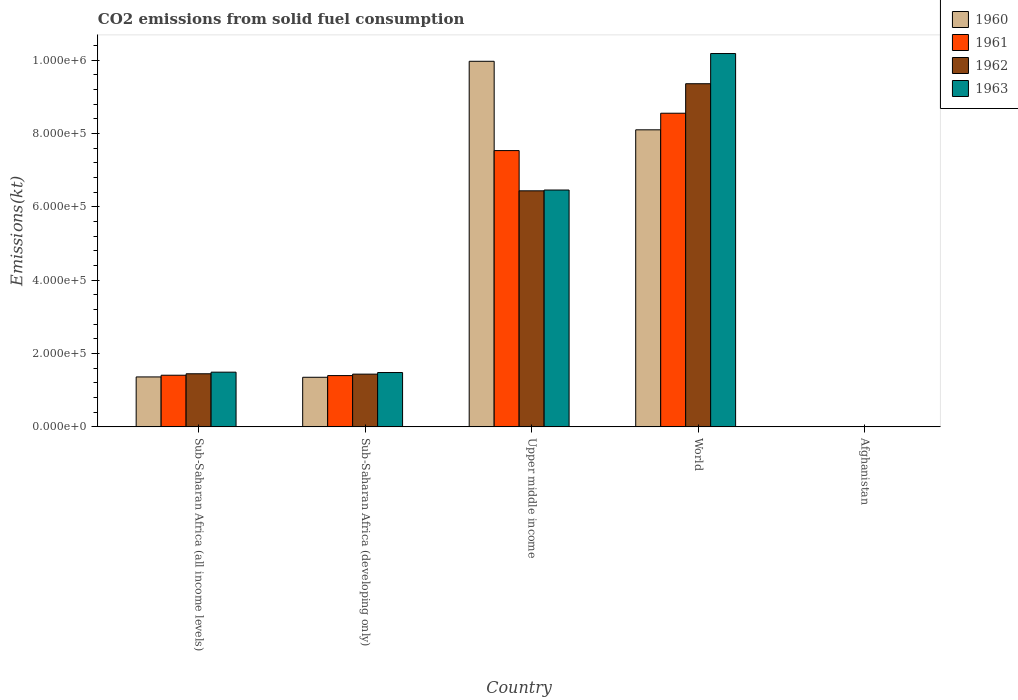Are the number of bars per tick equal to the number of legend labels?
Ensure brevity in your answer.  Yes. Are the number of bars on each tick of the X-axis equal?
Offer a very short reply. Yes. How many bars are there on the 5th tick from the left?
Your response must be concise. 4. What is the label of the 1st group of bars from the left?
Your answer should be very brief. Sub-Saharan Africa (all income levels). What is the amount of CO2 emitted in 1963 in Upper middle income?
Offer a terse response. 6.46e+05. Across all countries, what is the maximum amount of CO2 emitted in 1962?
Provide a short and direct response. 9.36e+05. Across all countries, what is the minimum amount of CO2 emitted in 1961?
Your answer should be compact. 176.02. In which country was the amount of CO2 emitted in 1960 maximum?
Ensure brevity in your answer.  Upper middle income. In which country was the amount of CO2 emitted in 1960 minimum?
Offer a very short reply. Afghanistan. What is the total amount of CO2 emitted in 1960 in the graph?
Keep it short and to the point. 2.08e+06. What is the difference between the amount of CO2 emitted in 1960 in Sub-Saharan Africa (developing only) and that in Upper middle income?
Ensure brevity in your answer.  -8.62e+05. What is the difference between the amount of CO2 emitted in 1960 in Afghanistan and the amount of CO2 emitted in 1962 in Sub-Saharan Africa (all income levels)?
Keep it short and to the point. -1.45e+05. What is the average amount of CO2 emitted in 1962 per country?
Keep it short and to the point. 3.74e+05. What is the difference between the amount of CO2 emitted of/in 1961 and amount of CO2 emitted of/in 1962 in World?
Your answer should be very brief. -8.05e+04. What is the ratio of the amount of CO2 emitted in 1960 in Sub-Saharan Africa (all income levels) to that in World?
Give a very brief answer. 0.17. What is the difference between the highest and the second highest amount of CO2 emitted in 1963?
Your answer should be very brief. -8.69e+05. What is the difference between the highest and the lowest amount of CO2 emitted in 1960?
Make the answer very short. 9.97e+05. What does the 1st bar from the left in Sub-Saharan Africa (developing only) represents?
Make the answer very short. 1960. What does the 2nd bar from the right in World represents?
Your response must be concise. 1962. How many countries are there in the graph?
Your response must be concise. 5. Where does the legend appear in the graph?
Your response must be concise. Top right. How are the legend labels stacked?
Your response must be concise. Vertical. What is the title of the graph?
Ensure brevity in your answer.  CO2 emissions from solid fuel consumption. What is the label or title of the X-axis?
Provide a succinct answer. Country. What is the label or title of the Y-axis?
Offer a very short reply. Emissions(kt). What is the Emissions(kt) of 1960 in Sub-Saharan Africa (all income levels)?
Offer a terse response. 1.36e+05. What is the Emissions(kt) of 1961 in Sub-Saharan Africa (all income levels)?
Make the answer very short. 1.41e+05. What is the Emissions(kt) of 1962 in Sub-Saharan Africa (all income levels)?
Ensure brevity in your answer.  1.45e+05. What is the Emissions(kt) of 1963 in Sub-Saharan Africa (all income levels)?
Your answer should be very brief. 1.49e+05. What is the Emissions(kt) in 1960 in Sub-Saharan Africa (developing only)?
Your response must be concise. 1.35e+05. What is the Emissions(kt) of 1961 in Sub-Saharan Africa (developing only)?
Your answer should be compact. 1.40e+05. What is the Emissions(kt) in 1962 in Sub-Saharan Africa (developing only)?
Provide a short and direct response. 1.44e+05. What is the Emissions(kt) in 1963 in Sub-Saharan Africa (developing only)?
Ensure brevity in your answer.  1.48e+05. What is the Emissions(kt) of 1960 in Upper middle income?
Provide a succinct answer. 9.97e+05. What is the Emissions(kt) in 1961 in Upper middle income?
Provide a succinct answer. 7.54e+05. What is the Emissions(kt) of 1962 in Upper middle income?
Offer a very short reply. 6.44e+05. What is the Emissions(kt) in 1963 in Upper middle income?
Provide a succinct answer. 6.46e+05. What is the Emissions(kt) of 1960 in World?
Ensure brevity in your answer.  8.10e+05. What is the Emissions(kt) in 1961 in World?
Provide a short and direct response. 8.56e+05. What is the Emissions(kt) in 1962 in World?
Make the answer very short. 9.36e+05. What is the Emissions(kt) of 1963 in World?
Offer a terse response. 1.02e+06. What is the Emissions(kt) of 1960 in Afghanistan?
Your answer should be compact. 128.34. What is the Emissions(kt) in 1961 in Afghanistan?
Keep it short and to the point. 176.02. What is the Emissions(kt) in 1962 in Afghanistan?
Offer a terse response. 297.03. What is the Emissions(kt) of 1963 in Afghanistan?
Ensure brevity in your answer.  264.02. Across all countries, what is the maximum Emissions(kt) of 1960?
Your answer should be compact. 9.97e+05. Across all countries, what is the maximum Emissions(kt) of 1961?
Provide a succinct answer. 8.56e+05. Across all countries, what is the maximum Emissions(kt) of 1962?
Ensure brevity in your answer.  9.36e+05. Across all countries, what is the maximum Emissions(kt) of 1963?
Ensure brevity in your answer.  1.02e+06. Across all countries, what is the minimum Emissions(kt) of 1960?
Offer a terse response. 128.34. Across all countries, what is the minimum Emissions(kt) of 1961?
Keep it short and to the point. 176.02. Across all countries, what is the minimum Emissions(kt) in 1962?
Your answer should be very brief. 297.03. Across all countries, what is the minimum Emissions(kt) in 1963?
Your answer should be compact. 264.02. What is the total Emissions(kt) of 1960 in the graph?
Ensure brevity in your answer.  2.08e+06. What is the total Emissions(kt) in 1961 in the graph?
Provide a short and direct response. 1.89e+06. What is the total Emissions(kt) of 1962 in the graph?
Give a very brief answer. 1.87e+06. What is the total Emissions(kt) in 1963 in the graph?
Your answer should be very brief. 1.96e+06. What is the difference between the Emissions(kt) in 1960 in Sub-Saharan Africa (all income levels) and that in Sub-Saharan Africa (developing only)?
Your response must be concise. 947.7. What is the difference between the Emissions(kt) of 1961 in Sub-Saharan Africa (all income levels) and that in Sub-Saharan Africa (developing only)?
Your answer should be compact. 979.79. What is the difference between the Emissions(kt) in 1962 in Sub-Saharan Africa (all income levels) and that in Sub-Saharan Africa (developing only)?
Your answer should be very brief. 1007.5. What is the difference between the Emissions(kt) in 1963 in Sub-Saharan Africa (all income levels) and that in Sub-Saharan Africa (developing only)?
Offer a terse response. 1037.94. What is the difference between the Emissions(kt) in 1960 in Sub-Saharan Africa (all income levels) and that in Upper middle income?
Provide a short and direct response. -8.61e+05. What is the difference between the Emissions(kt) of 1961 in Sub-Saharan Africa (all income levels) and that in Upper middle income?
Offer a terse response. -6.13e+05. What is the difference between the Emissions(kt) of 1962 in Sub-Saharan Africa (all income levels) and that in Upper middle income?
Your response must be concise. -4.99e+05. What is the difference between the Emissions(kt) in 1963 in Sub-Saharan Africa (all income levels) and that in Upper middle income?
Keep it short and to the point. -4.97e+05. What is the difference between the Emissions(kt) in 1960 in Sub-Saharan Africa (all income levels) and that in World?
Your answer should be compact. -6.74e+05. What is the difference between the Emissions(kt) of 1961 in Sub-Saharan Africa (all income levels) and that in World?
Your answer should be compact. -7.15e+05. What is the difference between the Emissions(kt) of 1962 in Sub-Saharan Africa (all income levels) and that in World?
Make the answer very short. -7.91e+05. What is the difference between the Emissions(kt) of 1963 in Sub-Saharan Africa (all income levels) and that in World?
Ensure brevity in your answer.  -8.69e+05. What is the difference between the Emissions(kt) of 1960 in Sub-Saharan Africa (all income levels) and that in Afghanistan?
Give a very brief answer. 1.36e+05. What is the difference between the Emissions(kt) in 1961 in Sub-Saharan Africa (all income levels) and that in Afghanistan?
Your answer should be compact. 1.41e+05. What is the difference between the Emissions(kt) in 1962 in Sub-Saharan Africa (all income levels) and that in Afghanistan?
Provide a short and direct response. 1.45e+05. What is the difference between the Emissions(kt) in 1963 in Sub-Saharan Africa (all income levels) and that in Afghanistan?
Your answer should be compact. 1.49e+05. What is the difference between the Emissions(kt) in 1960 in Sub-Saharan Africa (developing only) and that in Upper middle income?
Your response must be concise. -8.62e+05. What is the difference between the Emissions(kt) of 1961 in Sub-Saharan Africa (developing only) and that in Upper middle income?
Your answer should be compact. -6.14e+05. What is the difference between the Emissions(kt) in 1962 in Sub-Saharan Africa (developing only) and that in Upper middle income?
Keep it short and to the point. -5.00e+05. What is the difference between the Emissions(kt) of 1963 in Sub-Saharan Africa (developing only) and that in Upper middle income?
Give a very brief answer. -4.98e+05. What is the difference between the Emissions(kt) in 1960 in Sub-Saharan Africa (developing only) and that in World?
Provide a succinct answer. -6.75e+05. What is the difference between the Emissions(kt) of 1961 in Sub-Saharan Africa (developing only) and that in World?
Keep it short and to the point. -7.16e+05. What is the difference between the Emissions(kt) in 1962 in Sub-Saharan Africa (developing only) and that in World?
Make the answer very short. -7.92e+05. What is the difference between the Emissions(kt) in 1963 in Sub-Saharan Africa (developing only) and that in World?
Give a very brief answer. -8.70e+05. What is the difference between the Emissions(kt) in 1960 in Sub-Saharan Africa (developing only) and that in Afghanistan?
Offer a terse response. 1.35e+05. What is the difference between the Emissions(kt) in 1961 in Sub-Saharan Africa (developing only) and that in Afghanistan?
Your answer should be very brief. 1.40e+05. What is the difference between the Emissions(kt) in 1962 in Sub-Saharan Africa (developing only) and that in Afghanistan?
Offer a very short reply. 1.44e+05. What is the difference between the Emissions(kt) of 1963 in Sub-Saharan Africa (developing only) and that in Afghanistan?
Ensure brevity in your answer.  1.48e+05. What is the difference between the Emissions(kt) of 1960 in Upper middle income and that in World?
Offer a terse response. 1.87e+05. What is the difference between the Emissions(kt) in 1961 in Upper middle income and that in World?
Provide a succinct answer. -1.02e+05. What is the difference between the Emissions(kt) of 1962 in Upper middle income and that in World?
Give a very brief answer. -2.92e+05. What is the difference between the Emissions(kt) of 1963 in Upper middle income and that in World?
Your answer should be compact. -3.72e+05. What is the difference between the Emissions(kt) of 1960 in Upper middle income and that in Afghanistan?
Ensure brevity in your answer.  9.97e+05. What is the difference between the Emissions(kt) of 1961 in Upper middle income and that in Afghanistan?
Provide a short and direct response. 7.53e+05. What is the difference between the Emissions(kt) of 1962 in Upper middle income and that in Afghanistan?
Your answer should be very brief. 6.44e+05. What is the difference between the Emissions(kt) of 1963 in Upper middle income and that in Afghanistan?
Offer a terse response. 6.46e+05. What is the difference between the Emissions(kt) of 1960 in World and that in Afghanistan?
Ensure brevity in your answer.  8.10e+05. What is the difference between the Emissions(kt) of 1961 in World and that in Afghanistan?
Give a very brief answer. 8.55e+05. What is the difference between the Emissions(kt) in 1962 in World and that in Afghanistan?
Offer a terse response. 9.36e+05. What is the difference between the Emissions(kt) in 1963 in World and that in Afghanistan?
Offer a very short reply. 1.02e+06. What is the difference between the Emissions(kt) in 1960 in Sub-Saharan Africa (all income levels) and the Emissions(kt) in 1961 in Sub-Saharan Africa (developing only)?
Make the answer very short. -3634.8. What is the difference between the Emissions(kt) in 1960 in Sub-Saharan Africa (all income levels) and the Emissions(kt) in 1962 in Sub-Saharan Africa (developing only)?
Keep it short and to the point. -7591.49. What is the difference between the Emissions(kt) in 1960 in Sub-Saharan Africa (all income levels) and the Emissions(kt) in 1963 in Sub-Saharan Africa (developing only)?
Ensure brevity in your answer.  -1.19e+04. What is the difference between the Emissions(kt) in 1961 in Sub-Saharan Africa (all income levels) and the Emissions(kt) in 1962 in Sub-Saharan Africa (developing only)?
Offer a very short reply. -2976.9. What is the difference between the Emissions(kt) in 1961 in Sub-Saharan Africa (all income levels) and the Emissions(kt) in 1963 in Sub-Saharan Africa (developing only)?
Make the answer very short. -7322.24. What is the difference between the Emissions(kt) in 1962 in Sub-Saharan Africa (all income levels) and the Emissions(kt) in 1963 in Sub-Saharan Africa (developing only)?
Keep it short and to the point. -3337.84. What is the difference between the Emissions(kt) of 1960 in Sub-Saharan Africa (all income levels) and the Emissions(kt) of 1961 in Upper middle income?
Make the answer very short. -6.17e+05. What is the difference between the Emissions(kt) of 1960 in Sub-Saharan Africa (all income levels) and the Emissions(kt) of 1962 in Upper middle income?
Offer a very short reply. -5.08e+05. What is the difference between the Emissions(kt) in 1960 in Sub-Saharan Africa (all income levels) and the Emissions(kt) in 1963 in Upper middle income?
Your answer should be very brief. -5.10e+05. What is the difference between the Emissions(kt) of 1961 in Sub-Saharan Africa (all income levels) and the Emissions(kt) of 1962 in Upper middle income?
Your response must be concise. -5.03e+05. What is the difference between the Emissions(kt) in 1961 in Sub-Saharan Africa (all income levels) and the Emissions(kt) in 1963 in Upper middle income?
Your answer should be very brief. -5.05e+05. What is the difference between the Emissions(kt) in 1962 in Sub-Saharan Africa (all income levels) and the Emissions(kt) in 1963 in Upper middle income?
Ensure brevity in your answer.  -5.01e+05. What is the difference between the Emissions(kt) in 1960 in Sub-Saharan Africa (all income levels) and the Emissions(kt) in 1961 in World?
Offer a very short reply. -7.19e+05. What is the difference between the Emissions(kt) of 1960 in Sub-Saharan Africa (all income levels) and the Emissions(kt) of 1962 in World?
Offer a terse response. -8.00e+05. What is the difference between the Emissions(kt) in 1960 in Sub-Saharan Africa (all income levels) and the Emissions(kt) in 1963 in World?
Give a very brief answer. -8.82e+05. What is the difference between the Emissions(kt) in 1961 in Sub-Saharan Africa (all income levels) and the Emissions(kt) in 1962 in World?
Give a very brief answer. -7.95e+05. What is the difference between the Emissions(kt) in 1961 in Sub-Saharan Africa (all income levels) and the Emissions(kt) in 1963 in World?
Provide a succinct answer. -8.78e+05. What is the difference between the Emissions(kt) of 1962 in Sub-Saharan Africa (all income levels) and the Emissions(kt) of 1963 in World?
Ensure brevity in your answer.  -8.74e+05. What is the difference between the Emissions(kt) of 1960 in Sub-Saharan Africa (all income levels) and the Emissions(kt) of 1961 in Afghanistan?
Your answer should be compact. 1.36e+05. What is the difference between the Emissions(kt) of 1960 in Sub-Saharan Africa (all income levels) and the Emissions(kt) of 1962 in Afghanistan?
Offer a very short reply. 1.36e+05. What is the difference between the Emissions(kt) in 1960 in Sub-Saharan Africa (all income levels) and the Emissions(kt) in 1963 in Afghanistan?
Provide a succinct answer. 1.36e+05. What is the difference between the Emissions(kt) in 1961 in Sub-Saharan Africa (all income levels) and the Emissions(kt) in 1962 in Afghanistan?
Offer a very short reply. 1.41e+05. What is the difference between the Emissions(kt) in 1961 in Sub-Saharan Africa (all income levels) and the Emissions(kt) in 1963 in Afghanistan?
Give a very brief answer. 1.41e+05. What is the difference between the Emissions(kt) in 1962 in Sub-Saharan Africa (all income levels) and the Emissions(kt) in 1963 in Afghanistan?
Offer a terse response. 1.45e+05. What is the difference between the Emissions(kt) in 1960 in Sub-Saharan Africa (developing only) and the Emissions(kt) in 1961 in Upper middle income?
Keep it short and to the point. -6.18e+05. What is the difference between the Emissions(kt) of 1960 in Sub-Saharan Africa (developing only) and the Emissions(kt) of 1962 in Upper middle income?
Keep it short and to the point. -5.09e+05. What is the difference between the Emissions(kt) of 1960 in Sub-Saharan Africa (developing only) and the Emissions(kt) of 1963 in Upper middle income?
Your answer should be very brief. -5.11e+05. What is the difference between the Emissions(kt) in 1961 in Sub-Saharan Africa (developing only) and the Emissions(kt) in 1962 in Upper middle income?
Make the answer very short. -5.04e+05. What is the difference between the Emissions(kt) of 1961 in Sub-Saharan Africa (developing only) and the Emissions(kt) of 1963 in Upper middle income?
Your answer should be compact. -5.06e+05. What is the difference between the Emissions(kt) of 1962 in Sub-Saharan Africa (developing only) and the Emissions(kt) of 1963 in Upper middle income?
Provide a succinct answer. -5.02e+05. What is the difference between the Emissions(kt) in 1960 in Sub-Saharan Africa (developing only) and the Emissions(kt) in 1961 in World?
Give a very brief answer. -7.20e+05. What is the difference between the Emissions(kt) in 1960 in Sub-Saharan Africa (developing only) and the Emissions(kt) in 1962 in World?
Provide a short and direct response. -8.01e+05. What is the difference between the Emissions(kt) in 1960 in Sub-Saharan Africa (developing only) and the Emissions(kt) in 1963 in World?
Ensure brevity in your answer.  -8.83e+05. What is the difference between the Emissions(kt) in 1961 in Sub-Saharan Africa (developing only) and the Emissions(kt) in 1962 in World?
Give a very brief answer. -7.96e+05. What is the difference between the Emissions(kt) in 1961 in Sub-Saharan Africa (developing only) and the Emissions(kt) in 1963 in World?
Give a very brief answer. -8.79e+05. What is the difference between the Emissions(kt) of 1962 in Sub-Saharan Africa (developing only) and the Emissions(kt) of 1963 in World?
Offer a very short reply. -8.75e+05. What is the difference between the Emissions(kt) of 1960 in Sub-Saharan Africa (developing only) and the Emissions(kt) of 1961 in Afghanistan?
Keep it short and to the point. 1.35e+05. What is the difference between the Emissions(kt) in 1960 in Sub-Saharan Africa (developing only) and the Emissions(kt) in 1962 in Afghanistan?
Ensure brevity in your answer.  1.35e+05. What is the difference between the Emissions(kt) of 1960 in Sub-Saharan Africa (developing only) and the Emissions(kt) of 1963 in Afghanistan?
Offer a terse response. 1.35e+05. What is the difference between the Emissions(kt) in 1961 in Sub-Saharan Africa (developing only) and the Emissions(kt) in 1962 in Afghanistan?
Your answer should be very brief. 1.40e+05. What is the difference between the Emissions(kt) in 1961 in Sub-Saharan Africa (developing only) and the Emissions(kt) in 1963 in Afghanistan?
Your answer should be very brief. 1.40e+05. What is the difference between the Emissions(kt) of 1962 in Sub-Saharan Africa (developing only) and the Emissions(kt) of 1963 in Afghanistan?
Offer a very short reply. 1.44e+05. What is the difference between the Emissions(kt) in 1960 in Upper middle income and the Emissions(kt) in 1961 in World?
Ensure brevity in your answer.  1.42e+05. What is the difference between the Emissions(kt) in 1960 in Upper middle income and the Emissions(kt) in 1962 in World?
Offer a terse response. 6.12e+04. What is the difference between the Emissions(kt) in 1960 in Upper middle income and the Emissions(kt) in 1963 in World?
Your answer should be compact. -2.12e+04. What is the difference between the Emissions(kt) in 1961 in Upper middle income and the Emissions(kt) in 1962 in World?
Give a very brief answer. -1.82e+05. What is the difference between the Emissions(kt) in 1961 in Upper middle income and the Emissions(kt) in 1963 in World?
Your response must be concise. -2.65e+05. What is the difference between the Emissions(kt) of 1962 in Upper middle income and the Emissions(kt) of 1963 in World?
Your answer should be very brief. -3.74e+05. What is the difference between the Emissions(kt) of 1960 in Upper middle income and the Emissions(kt) of 1961 in Afghanistan?
Offer a terse response. 9.97e+05. What is the difference between the Emissions(kt) of 1960 in Upper middle income and the Emissions(kt) of 1962 in Afghanistan?
Provide a short and direct response. 9.97e+05. What is the difference between the Emissions(kt) of 1960 in Upper middle income and the Emissions(kt) of 1963 in Afghanistan?
Your answer should be compact. 9.97e+05. What is the difference between the Emissions(kt) in 1961 in Upper middle income and the Emissions(kt) in 1962 in Afghanistan?
Give a very brief answer. 7.53e+05. What is the difference between the Emissions(kt) in 1961 in Upper middle income and the Emissions(kt) in 1963 in Afghanistan?
Give a very brief answer. 7.53e+05. What is the difference between the Emissions(kt) in 1962 in Upper middle income and the Emissions(kt) in 1963 in Afghanistan?
Your answer should be compact. 6.44e+05. What is the difference between the Emissions(kt) of 1960 in World and the Emissions(kt) of 1961 in Afghanistan?
Your answer should be compact. 8.10e+05. What is the difference between the Emissions(kt) of 1960 in World and the Emissions(kt) of 1962 in Afghanistan?
Make the answer very short. 8.10e+05. What is the difference between the Emissions(kt) in 1960 in World and the Emissions(kt) in 1963 in Afghanistan?
Keep it short and to the point. 8.10e+05. What is the difference between the Emissions(kt) of 1961 in World and the Emissions(kt) of 1962 in Afghanistan?
Offer a terse response. 8.55e+05. What is the difference between the Emissions(kt) in 1961 in World and the Emissions(kt) in 1963 in Afghanistan?
Give a very brief answer. 8.55e+05. What is the difference between the Emissions(kt) in 1962 in World and the Emissions(kt) in 1963 in Afghanistan?
Make the answer very short. 9.36e+05. What is the average Emissions(kt) in 1960 per country?
Give a very brief answer. 4.16e+05. What is the average Emissions(kt) in 1961 per country?
Keep it short and to the point. 3.78e+05. What is the average Emissions(kt) in 1962 per country?
Provide a succinct answer. 3.74e+05. What is the average Emissions(kt) in 1963 per country?
Provide a short and direct response. 3.92e+05. What is the difference between the Emissions(kt) of 1960 and Emissions(kt) of 1961 in Sub-Saharan Africa (all income levels)?
Provide a succinct answer. -4614.59. What is the difference between the Emissions(kt) of 1960 and Emissions(kt) of 1962 in Sub-Saharan Africa (all income levels)?
Make the answer very short. -8598.99. What is the difference between the Emissions(kt) of 1960 and Emissions(kt) of 1963 in Sub-Saharan Africa (all income levels)?
Your response must be concise. -1.30e+04. What is the difference between the Emissions(kt) of 1961 and Emissions(kt) of 1962 in Sub-Saharan Africa (all income levels)?
Keep it short and to the point. -3984.4. What is the difference between the Emissions(kt) in 1961 and Emissions(kt) in 1963 in Sub-Saharan Africa (all income levels)?
Make the answer very short. -8360.18. What is the difference between the Emissions(kt) of 1962 and Emissions(kt) of 1963 in Sub-Saharan Africa (all income levels)?
Keep it short and to the point. -4375.77. What is the difference between the Emissions(kt) in 1960 and Emissions(kt) in 1961 in Sub-Saharan Africa (developing only)?
Keep it short and to the point. -4582.5. What is the difference between the Emissions(kt) of 1960 and Emissions(kt) of 1962 in Sub-Saharan Africa (developing only)?
Your answer should be very brief. -8539.18. What is the difference between the Emissions(kt) of 1960 and Emissions(kt) of 1963 in Sub-Saharan Africa (developing only)?
Provide a short and direct response. -1.29e+04. What is the difference between the Emissions(kt) of 1961 and Emissions(kt) of 1962 in Sub-Saharan Africa (developing only)?
Offer a very short reply. -3956.69. What is the difference between the Emissions(kt) of 1961 and Emissions(kt) of 1963 in Sub-Saharan Africa (developing only)?
Your response must be concise. -8302.03. What is the difference between the Emissions(kt) in 1962 and Emissions(kt) in 1963 in Sub-Saharan Africa (developing only)?
Keep it short and to the point. -4345.34. What is the difference between the Emissions(kt) of 1960 and Emissions(kt) of 1961 in Upper middle income?
Provide a short and direct response. 2.44e+05. What is the difference between the Emissions(kt) in 1960 and Emissions(kt) in 1962 in Upper middle income?
Ensure brevity in your answer.  3.53e+05. What is the difference between the Emissions(kt) in 1960 and Emissions(kt) in 1963 in Upper middle income?
Ensure brevity in your answer.  3.51e+05. What is the difference between the Emissions(kt) of 1961 and Emissions(kt) of 1962 in Upper middle income?
Provide a succinct answer. 1.10e+05. What is the difference between the Emissions(kt) in 1961 and Emissions(kt) in 1963 in Upper middle income?
Offer a terse response. 1.08e+05. What is the difference between the Emissions(kt) in 1962 and Emissions(kt) in 1963 in Upper middle income?
Your response must be concise. -2192.22. What is the difference between the Emissions(kt) of 1960 and Emissions(kt) of 1961 in World?
Offer a terse response. -4.53e+04. What is the difference between the Emissions(kt) in 1960 and Emissions(kt) in 1962 in World?
Your response must be concise. -1.26e+05. What is the difference between the Emissions(kt) of 1960 and Emissions(kt) of 1963 in World?
Provide a short and direct response. -2.08e+05. What is the difference between the Emissions(kt) in 1961 and Emissions(kt) in 1962 in World?
Your answer should be compact. -8.05e+04. What is the difference between the Emissions(kt) of 1961 and Emissions(kt) of 1963 in World?
Make the answer very short. -1.63e+05. What is the difference between the Emissions(kt) of 1962 and Emissions(kt) of 1963 in World?
Your answer should be very brief. -8.24e+04. What is the difference between the Emissions(kt) of 1960 and Emissions(kt) of 1961 in Afghanistan?
Keep it short and to the point. -47.67. What is the difference between the Emissions(kt) in 1960 and Emissions(kt) in 1962 in Afghanistan?
Provide a short and direct response. -168.68. What is the difference between the Emissions(kt) of 1960 and Emissions(kt) of 1963 in Afghanistan?
Your answer should be very brief. -135.68. What is the difference between the Emissions(kt) in 1961 and Emissions(kt) in 1962 in Afghanistan?
Your answer should be very brief. -121.01. What is the difference between the Emissions(kt) of 1961 and Emissions(kt) of 1963 in Afghanistan?
Keep it short and to the point. -88.01. What is the difference between the Emissions(kt) of 1962 and Emissions(kt) of 1963 in Afghanistan?
Make the answer very short. 33. What is the ratio of the Emissions(kt) in 1961 in Sub-Saharan Africa (all income levels) to that in Sub-Saharan Africa (developing only)?
Make the answer very short. 1.01. What is the ratio of the Emissions(kt) in 1960 in Sub-Saharan Africa (all income levels) to that in Upper middle income?
Keep it short and to the point. 0.14. What is the ratio of the Emissions(kt) in 1961 in Sub-Saharan Africa (all income levels) to that in Upper middle income?
Your answer should be very brief. 0.19. What is the ratio of the Emissions(kt) in 1962 in Sub-Saharan Africa (all income levels) to that in Upper middle income?
Offer a very short reply. 0.23. What is the ratio of the Emissions(kt) in 1963 in Sub-Saharan Africa (all income levels) to that in Upper middle income?
Give a very brief answer. 0.23. What is the ratio of the Emissions(kt) in 1960 in Sub-Saharan Africa (all income levels) to that in World?
Offer a very short reply. 0.17. What is the ratio of the Emissions(kt) of 1961 in Sub-Saharan Africa (all income levels) to that in World?
Your answer should be compact. 0.16. What is the ratio of the Emissions(kt) of 1962 in Sub-Saharan Africa (all income levels) to that in World?
Offer a very short reply. 0.15. What is the ratio of the Emissions(kt) in 1963 in Sub-Saharan Africa (all income levels) to that in World?
Offer a terse response. 0.15. What is the ratio of the Emissions(kt) in 1960 in Sub-Saharan Africa (all income levels) to that in Afghanistan?
Your answer should be compact. 1061.66. What is the ratio of the Emissions(kt) of 1961 in Sub-Saharan Africa (all income levels) to that in Afghanistan?
Give a very brief answer. 800.34. What is the ratio of the Emissions(kt) of 1962 in Sub-Saharan Africa (all income levels) to that in Afghanistan?
Make the answer very short. 487.69. What is the ratio of the Emissions(kt) in 1963 in Sub-Saharan Africa (all income levels) to that in Afghanistan?
Ensure brevity in your answer.  565.22. What is the ratio of the Emissions(kt) in 1960 in Sub-Saharan Africa (developing only) to that in Upper middle income?
Ensure brevity in your answer.  0.14. What is the ratio of the Emissions(kt) in 1961 in Sub-Saharan Africa (developing only) to that in Upper middle income?
Keep it short and to the point. 0.19. What is the ratio of the Emissions(kt) in 1962 in Sub-Saharan Africa (developing only) to that in Upper middle income?
Make the answer very short. 0.22. What is the ratio of the Emissions(kt) of 1963 in Sub-Saharan Africa (developing only) to that in Upper middle income?
Your response must be concise. 0.23. What is the ratio of the Emissions(kt) in 1960 in Sub-Saharan Africa (developing only) to that in World?
Provide a succinct answer. 0.17. What is the ratio of the Emissions(kt) of 1961 in Sub-Saharan Africa (developing only) to that in World?
Give a very brief answer. 0.16. What is the ratio of the Emissions(kt) in 1962 in Sub-Saharan Africa (developing only) to that in World?
Give a very brief answer. 0.15. What is the ratio of the Emissions(kt) of 1963 in Sub-Saharan Africa (developing only) to that in World?
Your answer should be very brief. 0.15. What is the ratio of the Emissions(kt) in 1960 in Sub-Saharan Africa (developing only) to that in Afghanistan?
Offer a terse response. 1054.27. What is the ratio of the Emissions(kt) in 1961 in Sub-Saharan Africa (developing only) to that in Afghanistan?
Make the answer very short. 794.77. What is the ratio of the Emissions(kt) in 1962 in Sub-Saharan Africa (developing only) to that in Afghanistan?
Give a very brief answer. 484.3. What is the ratio of the Emissions(kt) in 1963 in Sub-Saharan Africa (developing only) to that in Afghanistan?
Keep it short and to the point. 561.29. What is the ratio of the Emissions(kt) in 1960 in Upper middle income to that in World?
Offer a very short reply. 1.23. What is the ratio of the Emissions(kt) in 1961 in Upper middle income to that in World?
Provide a short and direct response. 0.88. What is the ratio of the Emissions(kt) in 1962 in Upper middle income to that in World?
Give a very brief answer. 0.69. What is the ratio of the Emissions(kt) in 1963 in Upper middle income to that in World?
Provide a short and direct response. 0.63. What is the ratio of the Emissions(kt) of 1960 in Upper middle income to that in Afghanistan?
Your answer should be compact. 7770.2. What is the ratio of the Emissions(kt) in 1961 in Upper middle income to that in Afghanistan?
Your answer should be very brief. 4281.81. What is the ratio of the Emissions(kt) of 1962 in Upper middle income to that in Afghanistan?
Provide a succinct answer. 2167.93. What is the ratio of the Emissions(kt) in 1963 in Upper middle income to that in Afghanistan?
Make the answer very short. 2447.22. What is the ratio of the Emissions(kt) in 1960 in World to that in Afghanistan?
Your answer should be compact. 6313.69. What is the ratio of the Emissions(kt) of 1961 in World to that in Afghanistan?
Provide a short and direct response. 4860.98. What is the ratio of the Emissions(kt) of 1962 in World to that in Afghanistan?
Give a very brief answer. 3151.44. What is the ratio of the Emissions(kt) in 1963 in World to that in Afghanistan?
Make the answer very short. 3857.29. What is the difference between the highest and the second highest Emissions(kt) in 1960?
Keep it short and to the point. 1.87e+05. What is the difference between the highest and the second highest Emissions(kt) of 1961?
Make the answer very short. 1.02e+05. What is the difference between the highest and the second highest Emissions(kt) in 1962?
Provide a succinct answer. 2.92e+05. What is the difference between the highest and the second highest Emissions(kt) of 1963?
Make the answer very short. 3.72e+05. What is the difference between the highest and the lowest Emissions(kt) in 1960?
Your answer should be very brief. 9.97e+05. What is the difference between the highest and the lowest Emissions(kt) in 1961?
Provide a succinct answer. 8.55e+05. What is the difference between the highest and the lowest Emissions(kt) of 1962?
Your answer should be very brief. 9.36e+05. What is the difference between the highest and the lowest Emissions(kt) in 1963?
Your response must be concise. 1.02e+06. 